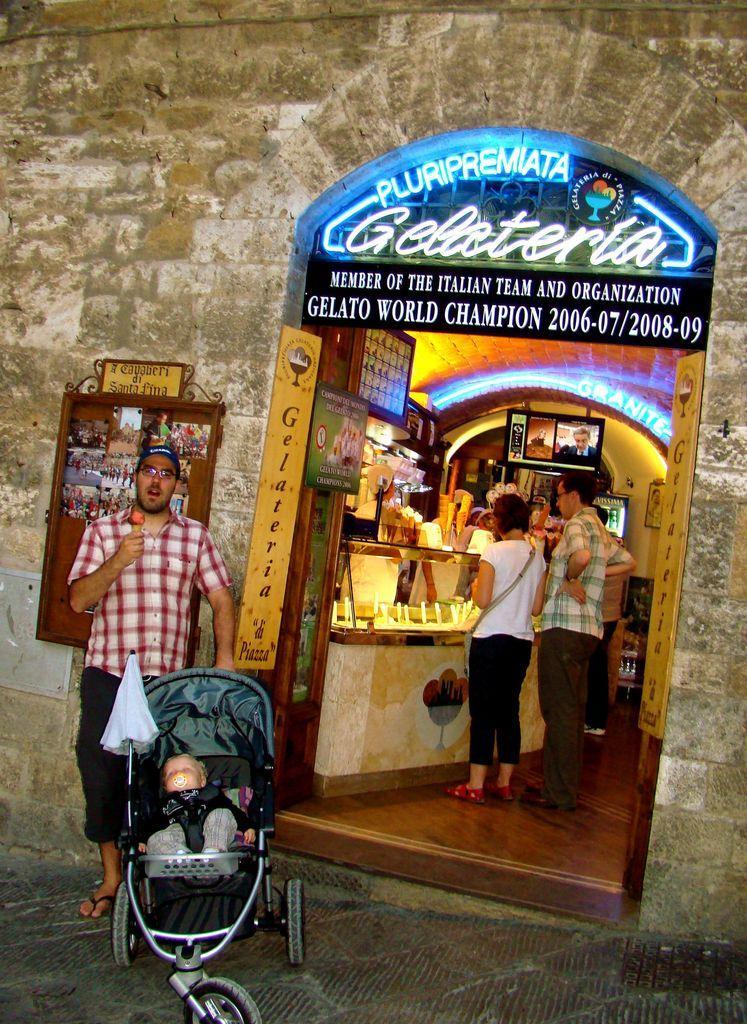Please provide a concise description of this image. The man in red check shirt is holding an ice cream in one of his hands and in the other hand, he is holding the trolley of the baby. Behind him, we see a building which is made up of cobblestones. Inside the building, we see two people standing in front of the table. In the background, we see a photo frame placed on the wall. This picture is clicked in the shop. On top of the building, we see a board with some text written on it. 